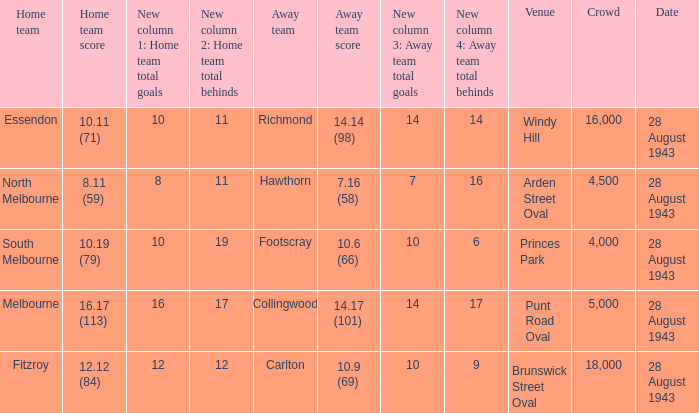17 (101)? Punt Road Oval. 